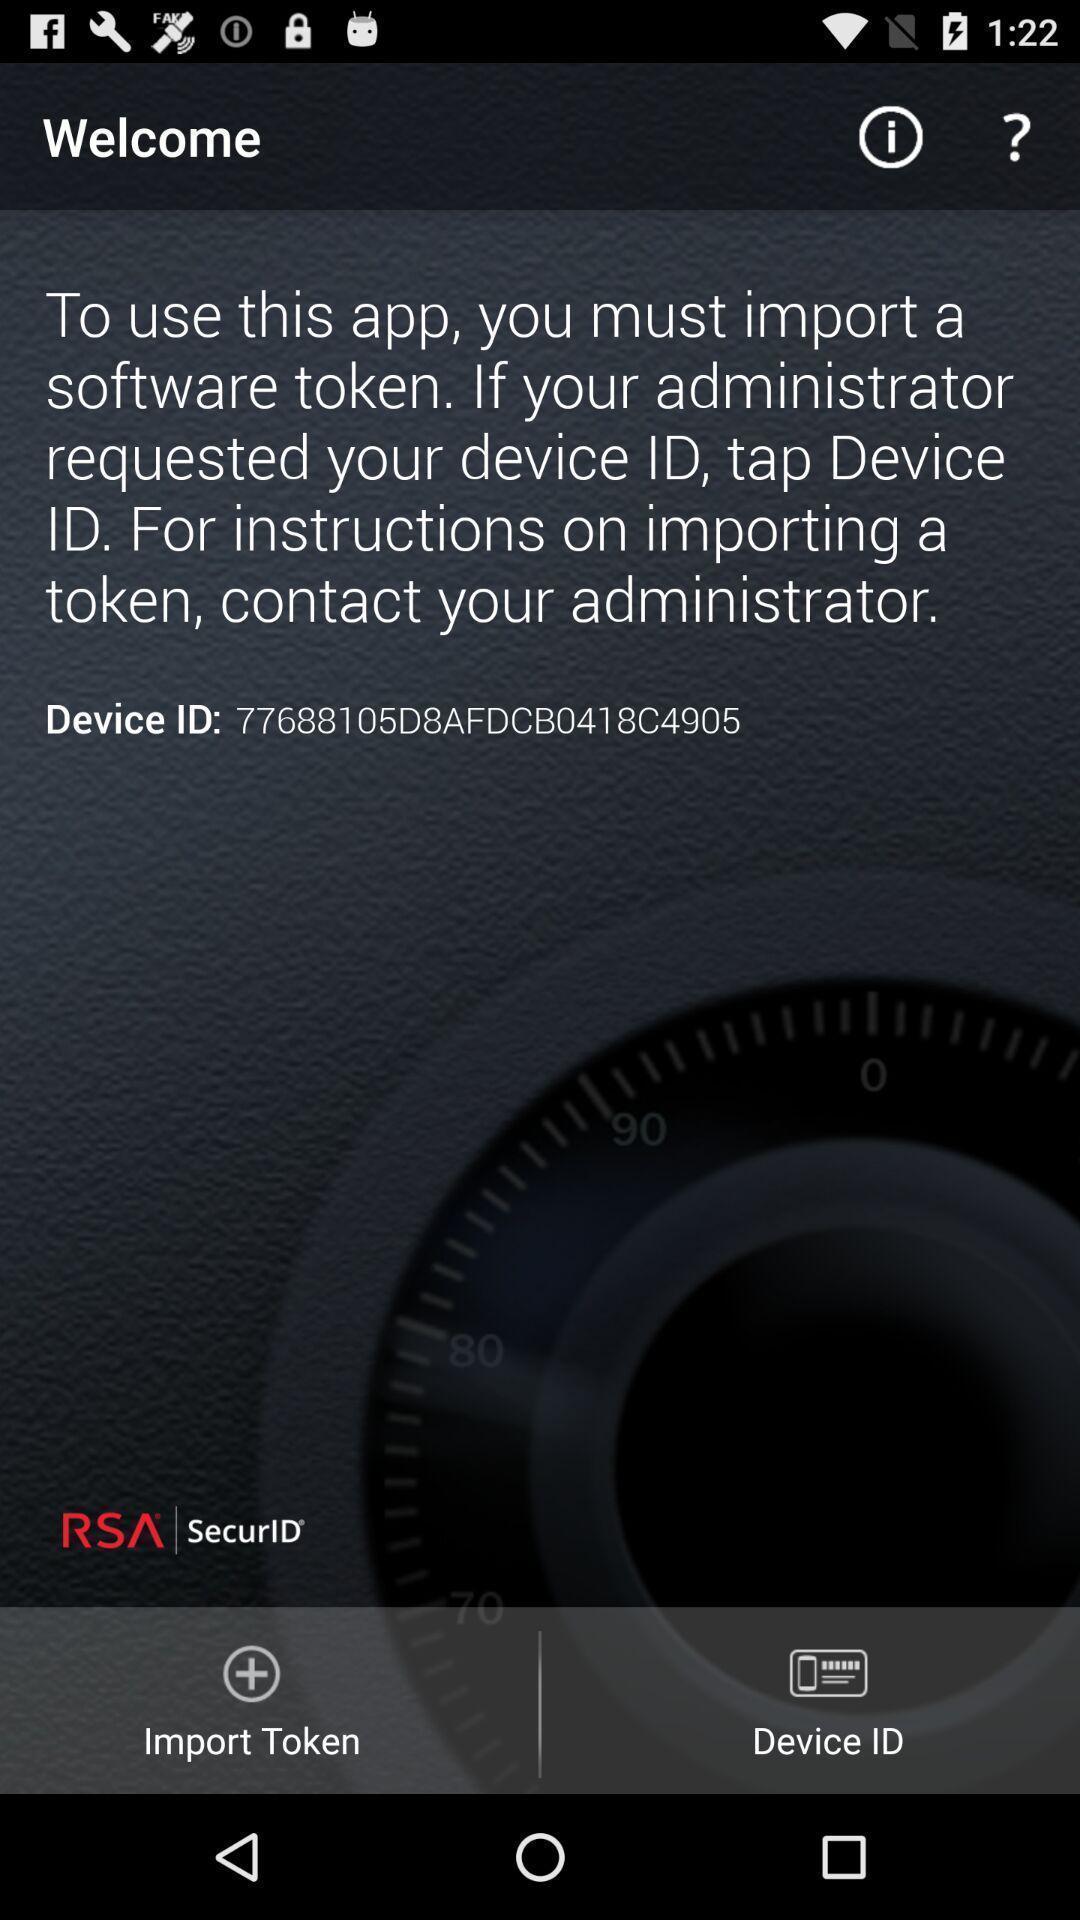Summarize the information in this screenshot. Welcome page with device id. 